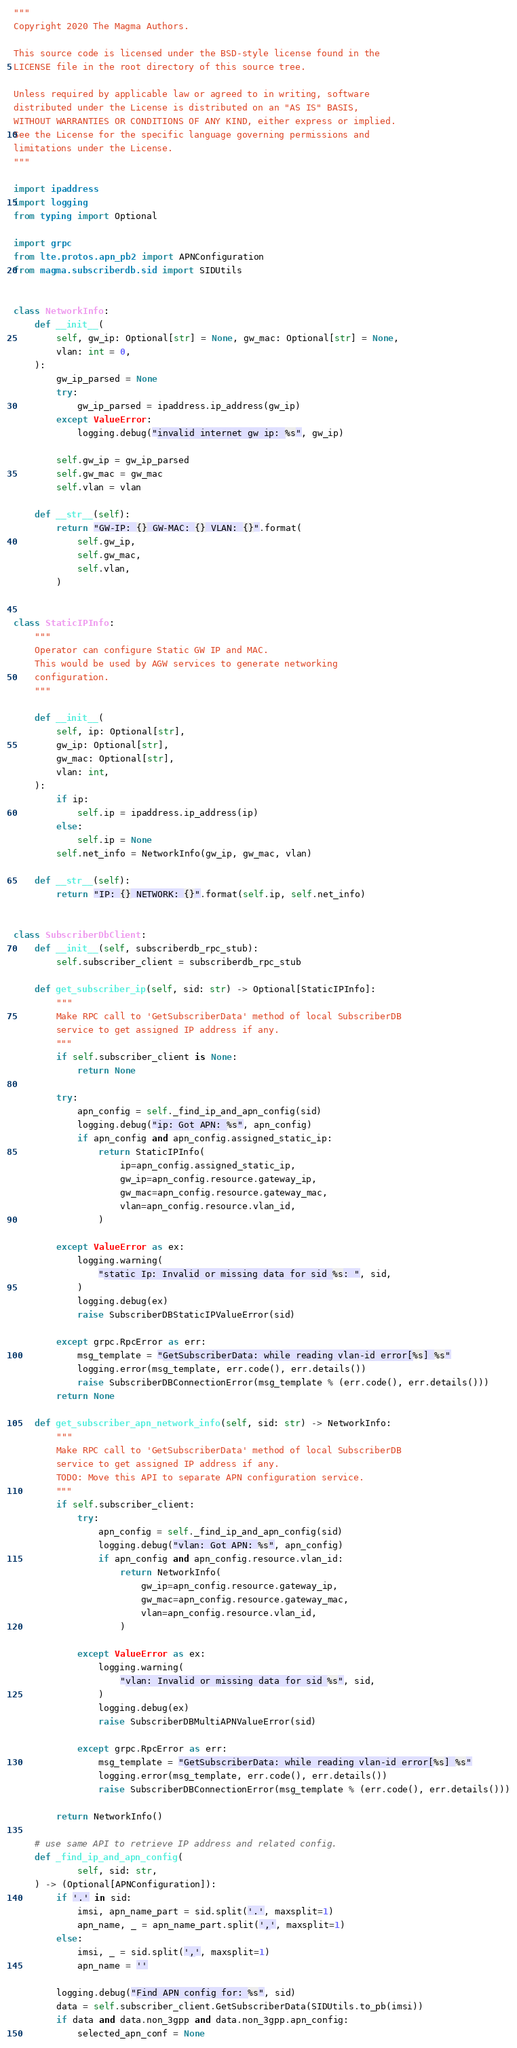<code> <loc_0><loc_0><loc_500><loc_500><_Python_>"""
Copyright 2020 The Magma Authors.

This source code is licensed under the BSD-style license found in the
LICENSE file in the root directory of this source tree.

Unless required by applicable law or agreed to in writing, software
distributed under the License is distributed on an "AS IS" BASIS,
WITHOUT WARRANTIES OR CONDITIONS OF ANY KIND, either express or implied.
See the License for the specific language governing permissions and
limitations under the License.
"""

import ipaddress
import logging
from typing import Optional

import grpc
from lte.protos.apn_pb2 import APNConfiguration
from magma.subscriberdb.sid import SIDUtils


class NetworkInfo:
    def __init__(
        self, gw_ip: Optional[str] = None, gw_mac: Optional[str] = None,
        vlan: int = 0,
    ):
        gw_ip_parsed = None
        try:
            gw_ip_parsed = ipaddress.ip_address(gw_ip)
        except ValueError:
            logging.debug("invalid internet gw ip: %s", gw_ip)

        self.gw_ip = gw_ip_parsed
        self.gw_mac = gw_mac
        self.vlan = vlan

    def __str__(self):
        return "GW-IP: {} GW-MAC: {} VLAN: {}".format(
            self.gw_ip,
            self.gw_mac,
            self.vlan,
        )


class StaticIPInfo:
    """
    Operator can configure Static GW IP and MAC.
    This would be used by AGW services to generate networking
    configuration.
    """

    def __init__(
        self, ip: Optional[str],
        gw_ip: Optional[str],
        gw_mac: Optional[str],
        vlan: int,
    ):
        if ip:
            self.ip = ipaddress.ip_address(ip)
        else:
            self.ip = None
        self.net_info = NetworkInfo(gw_ip, gw_mac, vlan)

    def __str__(self):
        return "IP: {} NETWORK: {}".format(self.ip, self.net_info)


class SubscriberDbClient:
    def __init__(self, subscriberdb_rpc_stub):
        self.subscriber_client = subscriberdb_rpc_stub

    def get_subscriber_ip(self, sid: str) -> Optional[StaticIPInfo]:
        """
        Make RPC call to 'GetSubscriberData' method of local SubscriberDB
        service to get assigned IP address if any.
        """
        if self.subscriber_client is None:
            return None

        try:
            apn_config = self._find_ip_and_apn_config(sid)
            logging.debug("ip: Got APN: %s", apn_config)
            if apn_config and apn_config.assigned_static_ip:
                return StaticIPInfo(
                    ip=apn_config.assigned_static_ip,
                    gw_ip=apn_config.resource.gateway_ip,
                    gw_mac=apn_config.resource.gateway_mac,
                    vlan=apn_config.resource.vlan_id,
                )

        except ValueError as ex:
            logging.warning(
                "static Ip: Invalid or missing data for sid %s: ", sid,
            )
            logging.debug(ex)
            raise SubscriberDBStaticIPValueError(sid)

        except grpc.RpcError as err:
            msg_template = "GetSubscriberData: while reading vlan-id error[%s] %s"
            logging.error(msg_template, err.code(), err.details())
            raise SubscriberDBConnectionError(msg_template % (err.code(), err.details()))
        return None

    def get_subscriber_apn_network_info(self, sid: str) -> NetworkInfo:
        """
        Make RPC call to 'GetSubscriberData' method of local SubscriberDB
        service to get assigned IP address if any.
        TODO: Move this API to separate APN configuration service.
        """
        if self.subscriber_client:
            try:
                apn_config = self._find_ip_and_apn_config(sid)
                logging.debug("vlan: Got APN: %s", apn_config)
                if apn_config and apn_config.resource.vlan_id:
                    return NetworkInfo(
                        gw_ip=apn_config.resource.gateway_ip,
                        gw_mac=apn_config.resource.gateway_mac,
                        vlan=apn_config.resource.vlan_id,
                    )

            except ValueError as ex:
                logging.warning(
                    "vlan: Invalid or missing data for sid %s", sid,
                )
                logging.debug(ex)
                raise SubscriberDBMultiAPNValueError(sid)

            except grpc.RpcError as err:
                msg_template = "GetSubscriberData: while reading vlan-id error[%s] %s"
                logging.error(msg_template, err.code(), err.details())
                raise SubscriberDBConnectionError(msg_template % (err.code(), err.details()))

        return NetworkInfo()

    # use same API to retrieve IP address and related config.
    def _find_ip_and_apn_config(
            self, sid: str,
    ) -> (Optional[APNConfiguration]):
        if '.' in sid:
            imsi, apn_name_part = sid.split('.', maxsplit=1)
            apn_name, _ = apn_name_part.split(',', maxsplit=1)
        else:
            imsi, _ = sid.split(',', maxsplit=1)
            apn_name = ''

        logging.debug("Find APN config for: %s", sid)
        data = self.subscriber_client.GetSubscriberData(SIDUtils.to_pb(imsi))
        if data and data.non_3gpp and data.non_3gpp.apn_config:
            selected_apn_conf = None</code> 